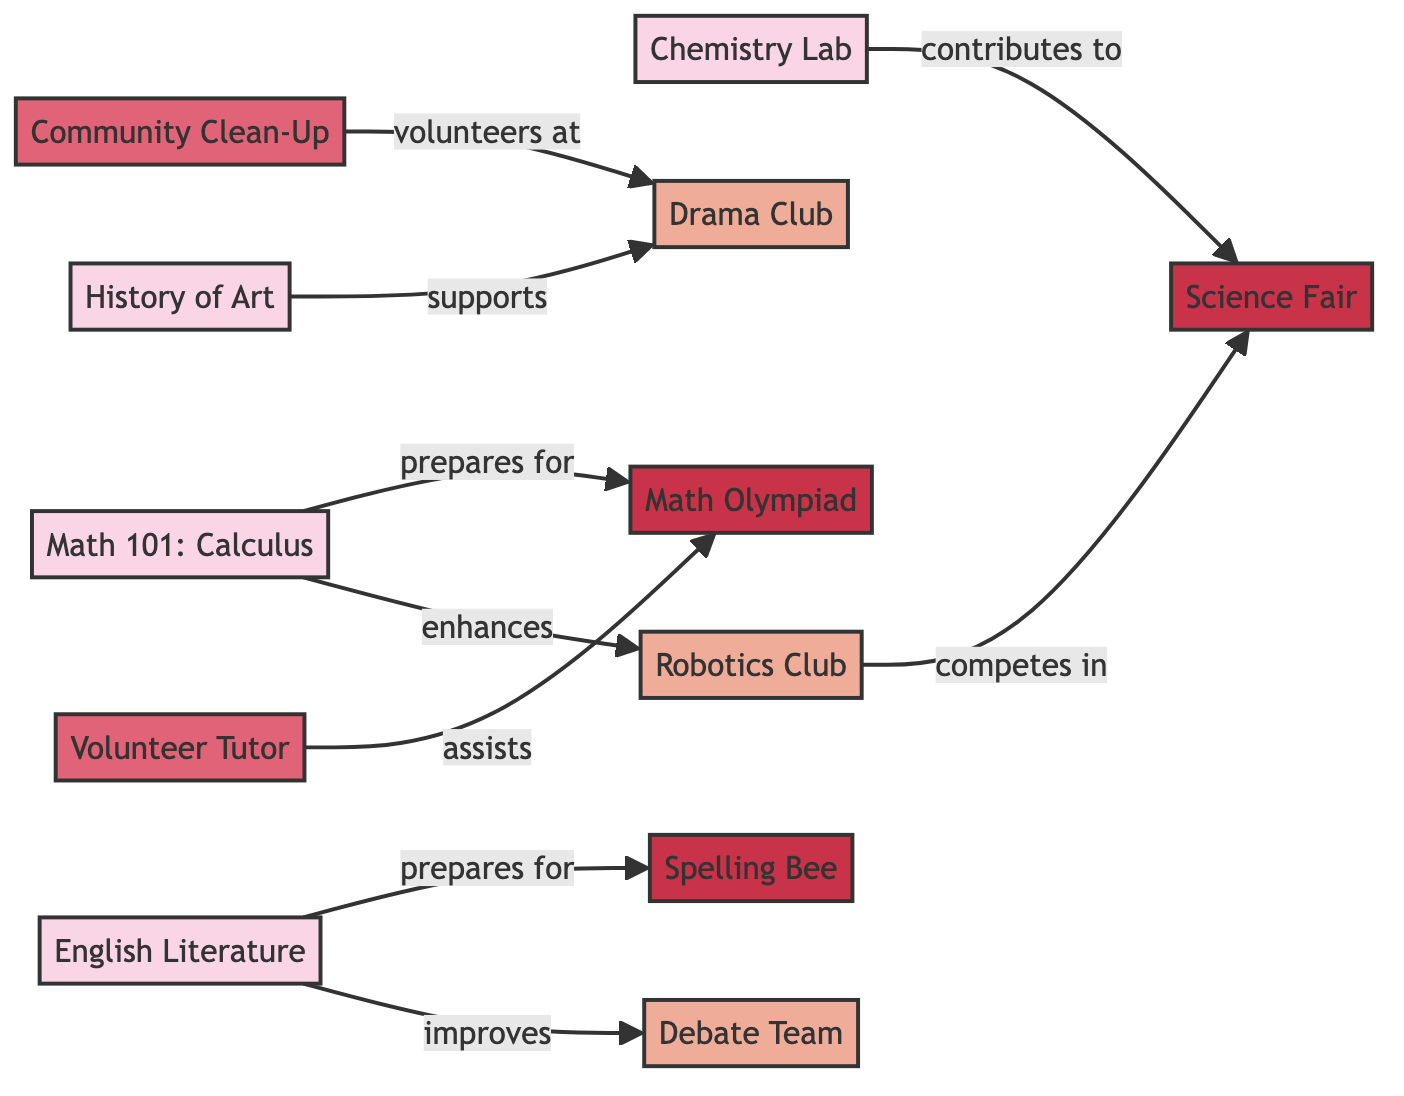What is the label of the node that represents a volunteering activity? The diagram contains multiple nodes representing different types of activities. The volunteering activities are represented by 'Volunteer Tutor' and 'Community Clean-Up'. The first relevant node extracted from the list is labeled 'Volunteer Tutor'.
Answer: Volunteer Tutor How many courses are represented in the diagram? The node list shows four nodes with the label "course," which are 'Math 101: Calculus', 'English Literature', 'Chemistry Lab', and 'History of Art'. Counting these nodes gives a total of four courses.
Answer: 4 What relationship exists between 'English Literature' and 'Debate Team'? The edge between these two nodes indicates that 'English Literature' improves 'Debate Team'. This direct relationship demonstrates that taking the English Literature course is beneficial to participating in the Debate Team.
Answer: improves Which club competes in the Science Fair? The edge shows that the 'Robotics Club' competes in the 'Science Fair'. This relationship indicates that members of the Robotics Club engage in the Science Fair competition.
Answer: Robotics Club How many volunteer activities are listed in the diagram? There are two nodes labeled as volunteering activities: 'Volunteer Tutor' and 'Community Clean-Up'. Thus, the total number of volunteering activities is two.
Answer: 2 Which course enhances participation in the Robotics Club? The edge indicates that 'Math 101: Calculus' enhances the participation in the 'Robotics Club'. This means that knowledge gained in this course contributes positively to being involved in the Robotics Club.
Answer: Math 101: Calculus What does the 'Volunteer Tutor' assist with? The directed edge shows that 'Volunteer Tutor' assists with the 'Math Olympiad'. This indicates that the role of a volunteer tutor is to help participants preparing for this specific competition.
Answer: Math Olympiad Which activity does the 'Drama Club' support? The edge indicates that the 'History of Art' course supports the 'Drama Club'. This means that the content or skills learned in the History of Art course are beneficial for the Drama Club.
Answer: Drama Club 